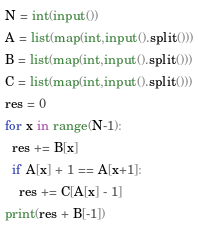Convert code to text. <code><loc_0><loc_0><loc_500><loc_500><_Python_>N = int(input())
A = list(map(int,input().split()))
B = list(map(int,input().split()))
C = list(map(int,input().split()))
res = 0
for x in range(N-1):
  res += B[x]
  if A[x] + 1 == A[x+1]:
    res += C[A[x] - 1]
print(res + B[-1])</code> 